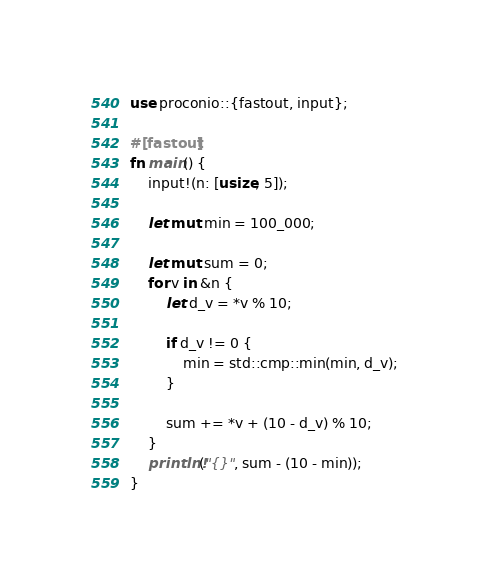<code> <loc_0><loc_0><loc_500><loc_500><_Rust_>use proconio::{fastout, input};

#[fastout]
fn main() {
    input!(n: [usize; 5]);

    let mut min = 100_000;

    let mut sum = 0;
    for v in &n {
        let d_v = *v % 10;

        if d_v != 0 {
            min = std::cmp::min(min, d_v);
        }

        sum += *v + (10 - d_v) % 10;
    }
    println!("{}", sum - (10 - min));
}
</code> 